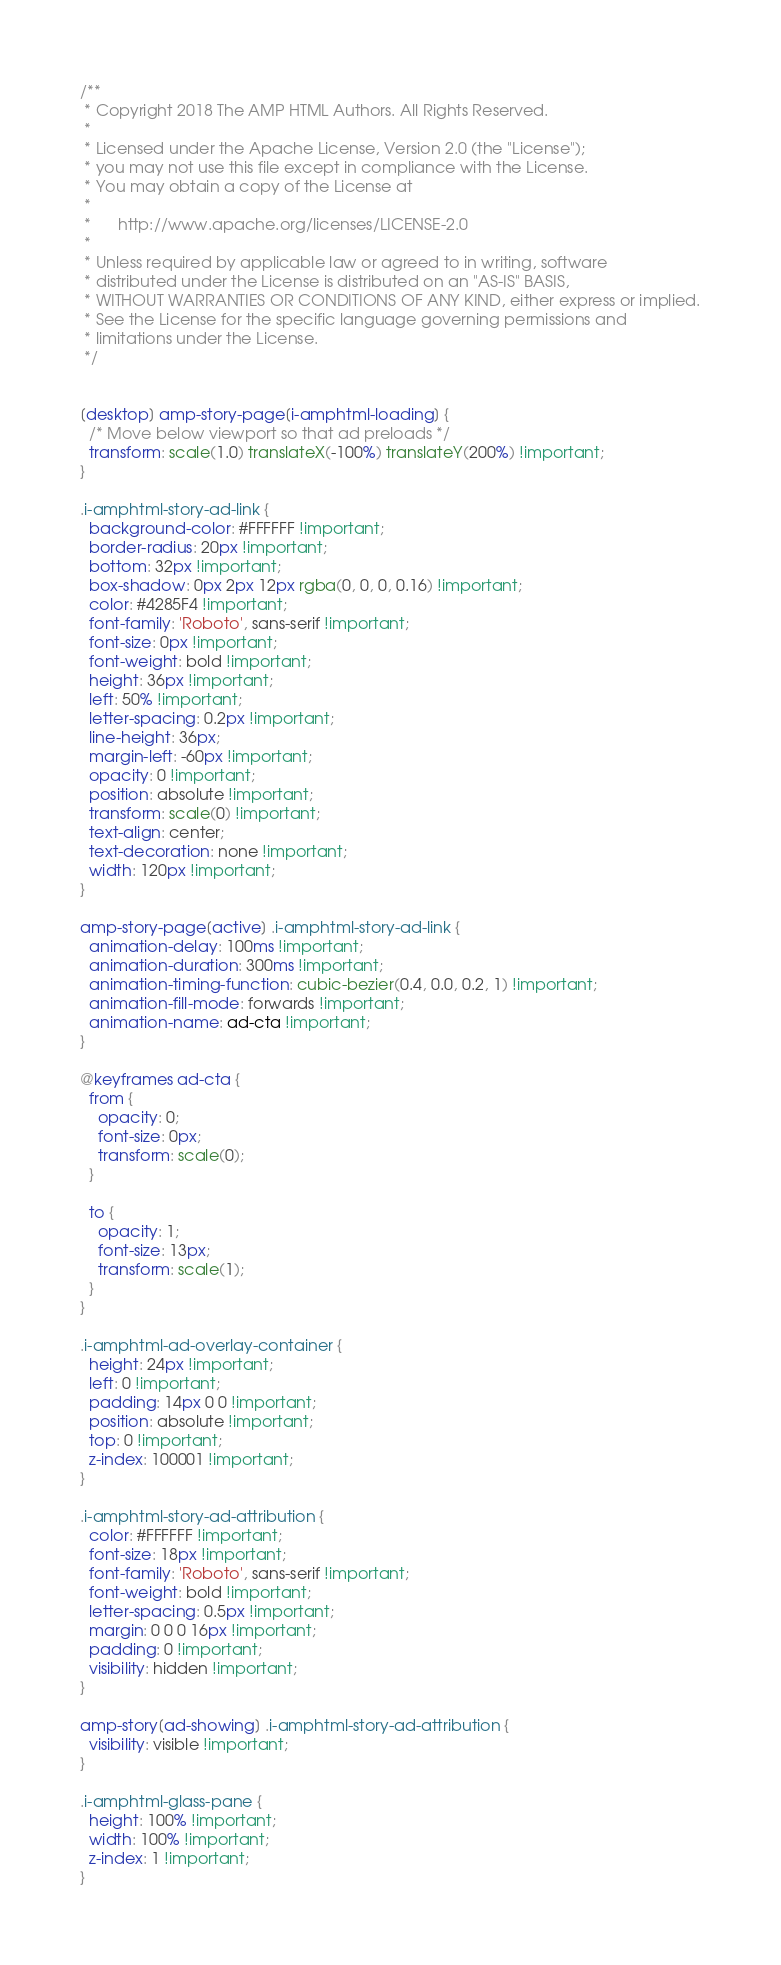Convert code to text. <code><loc_0><loc_0><loc_500><loc_500><_CSS_>/**
 * Copyright 2018 The AMP HTML Authors. All Rights Reserved.
 *
 * Licensed under the Apache License, Version 2.0 (the "License");
 * you may not use this file except in compliance with the License.
 * You may obtain a copy of the License at
 *
 *      http://www.apache.org/licenses/LICENSE-2.0
 *
 * Unless required by applicable law or agreed to in writing, software
 * distributed under the License is distributed on an "AS-IS" BASIS,
 * WITHOUT WARRANTIES OR CONDITIONS OF ANY KIND, either express or implied.
 * See the License for the specific language governing permissions and
 * limitations under the License.
 */


[desktop] amp-story-page[i-amphtml-loading] {
  /* Move below viewport so that ad preloads */
  transform: scale(1.0) translateX(-100%) translateY(200%) !important;
}

.i-amphtml-story-ad-link {
  background-color: #FFFFFF !important;
  border-radius: 20px !important;
  bottom: 32px !important;
  box-shadow: 0px 2px 12px rgba(0, 0, 0, 0.16) !important;
  color: #4285F4 !important;
  font-family: 'Roboto', sans-serif !important;
  font-size: 0px !important;
  font-weight: bold !important;
  height: 36px !important;
  left: 50% !important;
  letter-spacing: 0.2px !important;
  line-height: 36px;
  margin-left: -60px !important;
  opacity: 0 !important;
  position: absolute !important;
  transform: scale(0) !important;
  text-align: center;
  text-decoration: none !important;
  width: 120px !important;
}

amp-story-page[active] .i-amphtml-story-ad-link {
  animation-delay: 100ms !important;
  animation-duration: 300ms !important;
  animation-timing-function: cubic-bezier(0.4, 0.0, 0.2, 1) !important;
  animation-fill-mode: forwards !important;
  animation-name: ad-cta !important;
}

@keyframes ad-cta {
  from {
    opacity: 0;
    font-size: 0px;
    transform: scale(0);
  }

  to {
    opacity: 1;
    font-size: 13px;
    transform: scale(1);
  }
}

.i-amphtml-ad-overlay-container {
  height: 24px !important;
  left: 0 !important;
  padding: 14px 0 0 !important;
  position: absolute !important;
  top: 0 !important;
  z-index: 100001 !important;
}

.i-amphtml-story-ad-attribution {
  color: #FFFFFF !important;
  font-size: 18px !important;
  font-family: 'Roboto', sans-serif !important;
  font-weight: bold !important;
  letter-spacing: 0.5px !important;
  margin: 0 0 0 16px !important;
  padding: 0 !important;
  visibility: hidden !important;
}

amp-story[ad-showing] .i-amphtml-story-ad-attribution {
  visibility: visible !important;
}

.i-amphtml-glass-pane {
  height: 100% !important;
  width: 100% !important;
  z-index: 1 !important;
}
</code> 